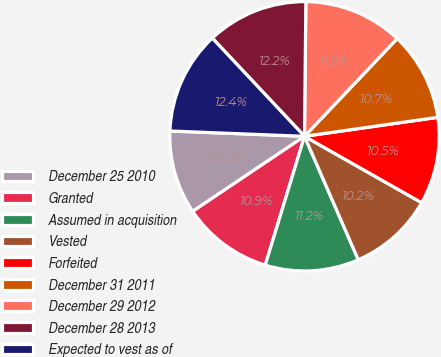Convert chart. <chart><loc_0><loc_0><loc_500><loc_500><pie_chart><fcel>December 25 2010<fcel>Granted<fcel>Assumed in acquisition<fcel>Vested<fcel>Forfeited<fcel>December 31 2011<fcel>December 29 2012<fcel>December 28 2013<fcel>Expected to vest as of<nl><fcel>10.04%<fcel>10.88%<fcel>11.25%<fcel>10.25%<fcel>10.46%<fcel>10.67%<fcel>11.92%<fcel>12.16%<fcel>12.37%<nl></chart> 